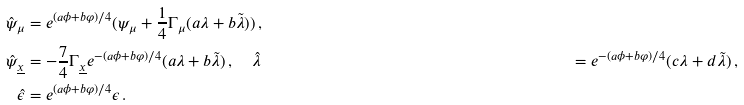<formula> <loc_0><loc_0><loc_500><loc_500>\hat { \psi } _ { \mu } & = e ^ { ( a \phi + b \varphi ) / 4 } ( \psi _ { \mu } + \frac { 1 } { 4 } \Gamma _ { \mu } ( a \lambda + b \tilde { \lambda } ) ) \, , \\ \hat { \psi } _ { \underline { x } } & = - \frac { 7 } { 4 } \Gamma _ { \underline { x } } e ^ { - ( a \phi + b \varphi ) / 4 } ( a \lambda + b \tilde { \lambda } ) \, , \quad \hat { \lambda } & = e ^ { - ( a \phi + b \varphi ) / 4 } ( c \lambda + d \tilde { \lambda } ) \, , \\ \hat { \epsilon } & = e ^ { ( a \phi + b \varphi ) / 4 } \epsilon \, .</formula> 